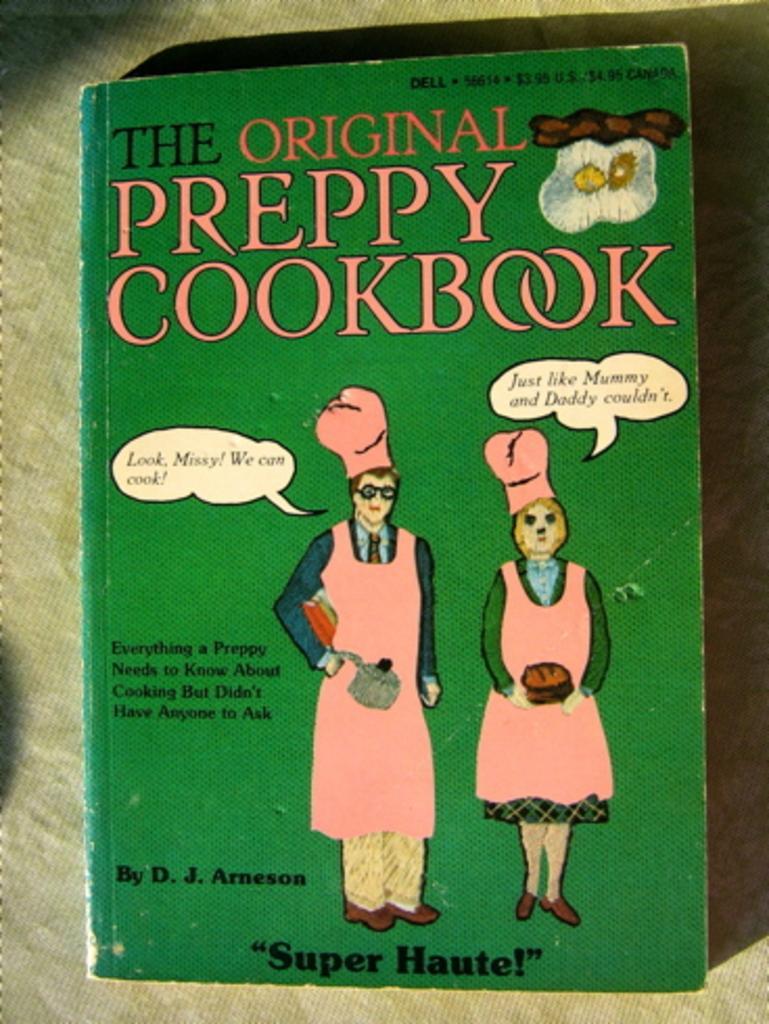Could you give a brief overview of what you see in this image? There is a book with the name the original preppy cookbook. In the book we can see two persons. 